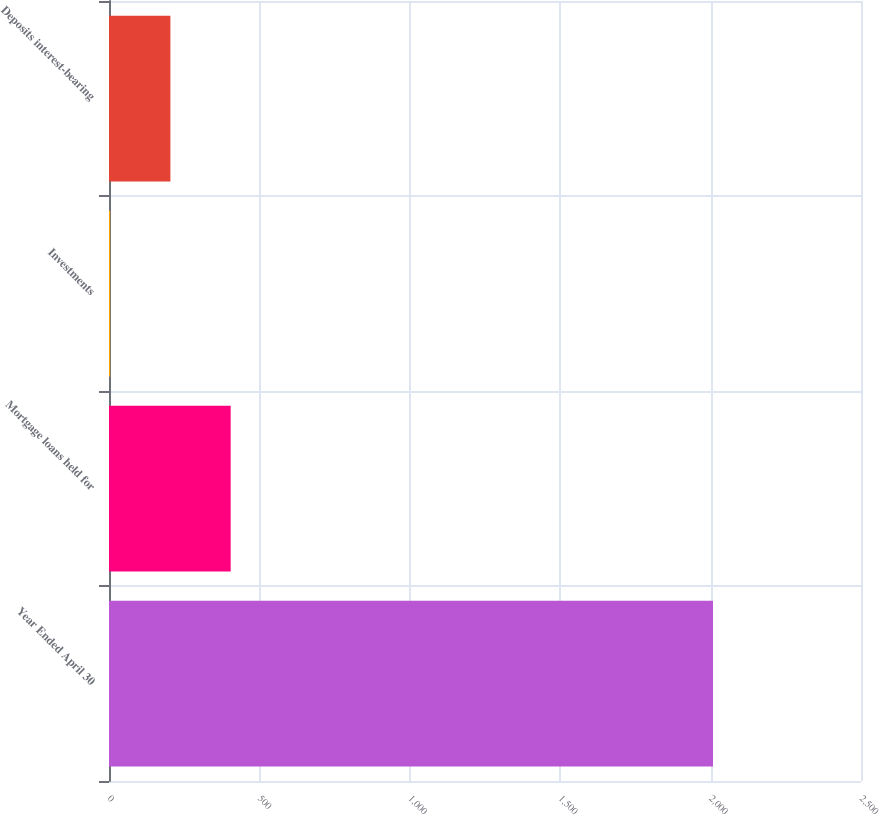Convert chart to OTSL. <chart><loc_0><loc_0><loc_500><loc_500><bar_chart><fcel>Year Ended April 30<fcel>Mortgage loans held for<fcel>Investments<fcel>Deposits interest-bearing<nl><fcel>2008<fcel>404.52<fcel>3.64<fcel>204.08<nl></chart> 